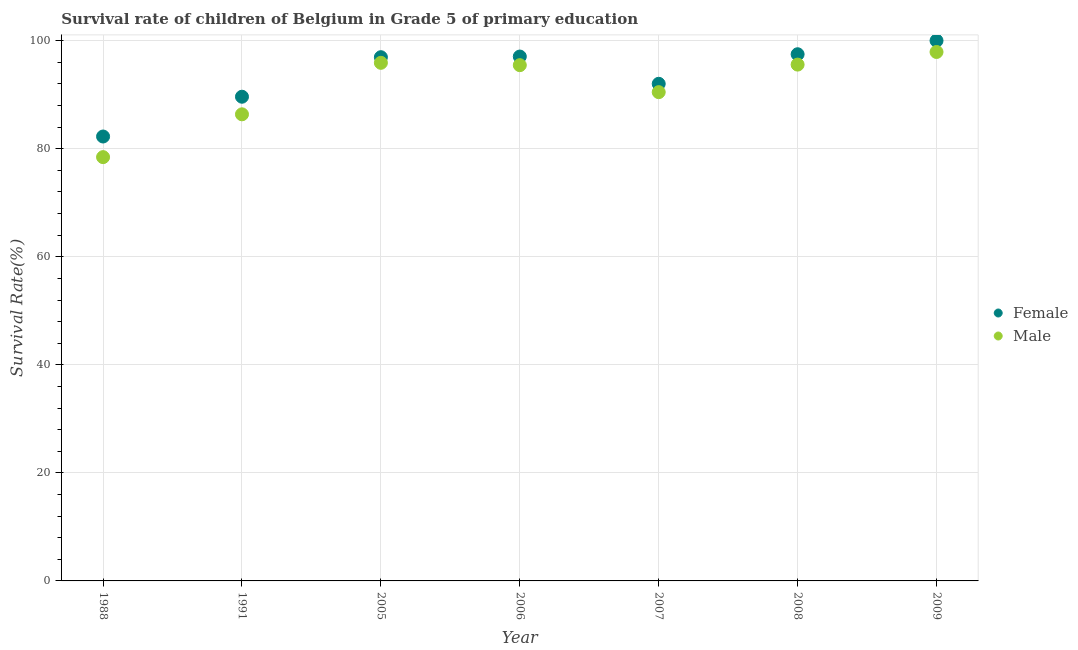Is the number of dotlines equal to the number of legend labels?
Keep it short and to the point. Yes. Across all years, what is the maximum survival rate of male students in primary education?
Offer a very short reply. 97.91. Across all years, what is the minimum survival rate of female students in primary education?
Your response must be concise. 82.26. In which year was the survival rate of male students in primary education minimum?
Offer a very short reply. 1988. What is the total survival rate of female students in primary education in the graph?
Your answer should be very brief. 655.42. What is the difference between the survival rate of female students in primary education in 1991 and that in 2006?
Your answer should be very brief. -7.44. What is the difference between the survival rate of male students in primary education in 2006 and the survival rate of female students in primary education in 1991?
Provide a succinct answer. 5.84. What is the average survival rate of male students in primary education per year?
Provide a succinct answer. 91.45. In the year 2009, what is the difference between the survival rate of female students in primary education and survival rate of male students in primary education?
Your answer should be compact. 2.09. In how many years, is the survival rate of female students in primary education greater than 88 %?
Provide a short and direct response. 6. What is the ratio of the survival rate of female students in primary education in 1991 to that in 2008?
Keep it short and to the point. 0.92. Is the survival rate of male students in primary education in 2006 less than that in 2009?
Provide a succinct answer. Yes. Is the difference between the survival rate of male students in primary education in 1988 and 2008 greater than the difference between the survival rate of female students in primary education in 1988 and 2008?
Keep it short and to the point. No. What is the difference between the highest and the second highest survival rate of male students in primary education?
Offer a very short reply. 2.01. What is the difference between the highest and the lowest survival rate of female students in primary education?
Offer a very short reply. 17.74. Is the sum of the survival rate of male students in primary education in 2006 and 2007 greater than the maximum survival rate of female students in primary education across all years?
Provide a short and direct response. Yes. Does the survival rate of male students in primary education monotonically increase over the years?
Offer a very short reply. No. Is the survival rate of male students in primary education strictly less than the survival rate of female students in primary education over the years?
Ensure brevity in your answer.  Yes. Does the graph contain any zero values?
Provide a short and direct response. No. How many legend labels are there?
Provide a succinct answer. 2. What is the title of the graph?
Your response must be concise. Survival rate of children of Belgium in Grade 5 of primary education. Does "Study and work" appear as one of the legend labels in the graph?
Provide a short and direct response. No. What is the label or title of the Y-axis?
Offer a very short reply. Survival Rate(%). What is the Survival Rate(%) in Female in 1988?
Your response must be concise. 82.26. What is the Survival Rate(%) of Male in 1988?
Your answer should be very brief. 78.45. What is the Survival Rate(%) in Female in 1991?
Make the answer very short. 89.63. What is the Survival Rate(%) in Male in 1991?
Keep it short and to the point. 86.37. What is the Survival Rate(%) of Female in 2005?
Keep it short and to the point. 96.95. What is the Survival Rate(%) in Male in 2005?
Keep it short and to the point. 95.91. What is the Survival Rate(%) in Female in 2006?
Give a very brief answer. 97.07. What is the Survival Rate(%) of Male in 2006?
Offer a terse response. 95.47. What is the Survival Rate(%) of Female in 2007?
Give a very brief answer. 92.02. What is the Survival Rate(%) in Male in 2007?
Give a very brief answer. 90.48. What is the Survival Rate(%) in Female in 2008?
Offer a very short reply. 97.49. What is the Survival Rate(%) in Male in 2008?
Provide a short and direct response. 95.58. What is the Survival Rate(%) in Female in 2009?
Your answer should be compact. 100. What is the Survival Rate(%) in Male in 2009?
Provide a short and direct response. 97.91. Across all years, what is the maximum Survival Rate(%) of Male?
Provide a succinct answer. 97.91. Across all years, what is the minimum Survival Rate(%) in Female?
Keep it short and to the point. 82.26. Across all years, what is the minimum Survival Rate(%) of Male?
Your answer should be compact. 78.45. What is the total Survival Rate(%) of Female in the graph?
Your answer should be very brief. 655.42. What is the total Survival Rate(%) of Male in the graph?
Your response must be concise. 640.16. What is the difference between the Survival Rate(%) of Female in 1988 and that in 1991?
Your answer should be compact. -7.36. What is the difference between the Survival Rate(%) of Male in 1988 and that in 1991?
Your answer should be compact. -7.93. What is the difference between the Survival Rate(%) in Female in 1988 and that in 2005?
Give a very brief answer. -14.68. What is the difference between the Survival Rate(%) of Male in 1988 and that in 2005?
Offer a very short reply. -17.46. What is the difference between the Survival Rate(%) in Female in 1988 and that in 2006?
Your answer should be very brief. -14.8. What is the difference between the Survival Rate(%) of Male in 1988 and that in 2006?
Provide a short and direct response. -17.02. What is the difference between the Survival Rate(%) of Female in 1988 and that in 2007?
Ensure brevity in your answer.  -9.76. What is the difference between the Survival Rate(%) in Male in 1988 and that in 2007?
Offer a terse response. -12.03. What is the difference between the Survival Rate(%) in Female in 1988 and that in 2008?
Your response must be concise. -15.23. What is the difference between the Survival Rate(%) in Male in 1988 and that in 2008?
Your response must be concise. -17.13. What is the difference between the Survival Rate(%) of Female in 1988 and that in 2009?
Your answer should be compact. -17.74. What is the difference between the Survival Rate(%) of Male in 1988 and that in 2009?
Keep it short and to the point. -19.47. What is the difference between the Survival Rate(%) in Female in 1991 and that in 2005?
Provide a short and direct response. -7.32. What is the difference between the Survival Rate(%) in Male in 1991 and that in 2005?
Ensure brevity in your answer.  -9.53. What is the difference between the Survival Rate(%) of Female in 1991 and that in 2006?
Your answer should be compact. -7.44. What is the difference between the Survival Rate(%) of Male in 1991 and that in 2006?
Your answer should be very brief. -9.1. What is the difference between the Survival Rate(%) of Female in 1991 and that in 2007?
Make the answer very short. -2.39. What is the difference between the Survival Rate(%) in Male in 1991 and that in 2007?
Your answer should be compact. -4.1. What is the difference between the Survival Rate(%) of Female in 1991 and that in 2008?
Make the answer very short. -7.86. What is the difference between the Survival Rate(%) of Male in 1991 and that in 2008?
Make the answer very short. -9.2. What is the difference between the Survival Rate(%) in Female in 1991 and that in 2009?
Offer a terse response. -10.37. What is the difference between the Survival Rate(%) of Male in 1991 and that in 2009?
Make the answer very short. -11.54. What is the difference between the Survival Rate(%) of Female in 2005 and that in 2006?
Offer a very short reply. -0.12. What is the difference between the Survival Rate(%) of Male in 2005 and that in 2006?
Keep it short and to the point. 0.43. What is the difference between the Survival Rate(%) of Female in 2005 and that in 2007?
Give a very brief answer. 4.92. What is the difference between the Survival Rate(%) in Male in 2005 and that in 2007?
Offer a terse response. 5.43. What is the difference between the Survival Rate(%) in Female in 2005 and that in 2008?
Provide a succinct answer. -0.55. What is the difference between the Survival Rate(%) of Male in 2005 and that in 2008?
Give a very brief answer. 0.33. What is the difference between the Survival Rate(%) of Female in 2005 and that in 2009?
Provide a short and direct response. -3.05. What is the difference between the Survival Rate(%) of Male in 2005 and that in 2009?
Make the answer very short. -2.01. What is the difference between the Survival Rate(%) of Female in 2006 and that in 2007?
Your answer should be very brief. 5.05. What is the difference between the Survival Rate(%) in Male in 2006 and that in 2007?
Your response must be concise. 5. What is the difference between the Survival Rate(%) of Female in 2006 and that in 2008?
Offer a terse response. -0.42. What is the difference between the Survival Rate(%) of Male in 2006 and that in 2008?
Provide a succinct answer. -0.1. What is the difference between the Survival Rate(%) in Female in 2006 and that in 2009?
Your answer should be very brief. -2.93. What is the difference between the Survival Rate(%) in Male in 2006 and that in 2009?
Your response must be concise. -2.44. What is the difference between the Survival Rate(%) of Female in 2007 and that in 2008?
Your answer should be very brief. -5.47. What is the difference between the Survival Rate(%) of Male in 2007 and that in 2008?
Your answer should be very brief. -5.1. What is the difference between the Survival Rate(%) of Female in 2007 and that in 2009?
Offer a very short reply. -7.98. What is the difference between the Survival Rate(%) in Male in 2007 and that in 2009?
Your response must be concise. -7.44. What is the difference between the Survival Rate(%) in Female in 2008 and that in 2009?
Provide a short and direct response. -2.51. What is the difference between the Survival Rate(%) in Male in 2008 and that in 2009?
Ensure brevity in your answer.  -2.34. What is the difference between the Survival Rate(%) of Female in 1988 and the Survival Rate(%) of Male in 1991?
Give a very brief answer. -4.11. What is the difference between the Survival Rate(%) of Female in 1988 and the Survival Rate(%) of Male in 2005?
Offer a very short reply. -13.64. What is the difference between the Survival Rate(%) of Female in 1988 and the Survival Rate(%) of Male in 2006?
Make the answer very short. -13.21. What is the difference between the Survival Rate(%) in Female in 1988 and the Survival Rate(%) in Male in 2007?
Provide a short and direct response. -8.21. What is the difference between the Survival Rate(%) in Female in 1988 and the Survival Rate(%) in Male in 2008?
Your answer should be very brief. -13.31. What is the difference between the Survival Rate(%) of Female in 1988 and the Survival Rate(%) of Male in 2009?
Offer a terse response. -15.65. What is the difference between the Survival Rate(%) of Female in 1991 and the Survival Rate(%) of Male in 2005?
Your answer should be compact. -6.28. What is the difference between the Survival Rate(%) in Female in 1991 and the Survival Rate(%) in Male in 2006?
Your answer should be very brief. -5.84. What is the difference between the Survival Rate(%) in Female in 1991 and the Survival Rate(%) in Male in 2007?
Provide a succinct answer. -0.85. What is the difference between the Survival Rate(%) in Female in 1991 and the Survival Rate(%) in Male in 2008?
Provide a short and direct response. -5.95. What is the difference between the Survival Rate(%) of Female in 1991 and the Survival Rate(%) of Male in 2009?
Your answer should be compact. -8.28. What is the difference between the Survival Rate(%) of Female in 2005 and the Survival Rate(%) of Male in 2006?
Keep it short and to the point. 1.47. What is the difference between the Survival Rate(%) in Female in 2005 and the Survival Rate(%) in Male in 2007?
Provide a succinct answer. 6.47. What is the difference between the Survival Rate(%) in Female in 2005 and the Survival Rate(%) in Male in 2008?
Offer a very short reply. 1.37. What is the difference between the Survival Rate(%) in Female in 2005 and the Survival Rate(%) in Male in 2009?
Ensure brevity in your answer.  -0.97. What is the difference between the Survival Rate(%) of Female in 2006 and the Survival Rate(%) of Male in 2007?
Make the answer very short. 6.59. What is the difference between the Survival Rate(%) in Female in 2006 and the Survival Rate(%) in Male in 2008?
Keep it short and to the point. 1.49. What is the difference between the Survival Rate(%) in Female in 2006 and the Survival Rate(%) in Male in 2009?
Offer a very short reply. -0.85. What is the difference between the Survival Rate(%) of Female in 2007 and the Survival Rate(%) of Male in 2008?
Ensure brevity in your answer.  -3.55. What is the difference between the Survival Rate(%) of Female in 2007 and the Survival Rate(%) of Male in 2009?
Give a very brief answer. -5.89. What is the difference between the Survival Rate(%) in Female in 2008 and the Survival Rate(%) in Male in 2009?
Provide a short and direct response. -0.42. What is the average Survival Rate(%) of Female per year?
Provide a succinct answer. 93.63. What is the average Survival Rate(%) of Male per year?
Your answer should be very brief. 91.45. In the year 1988, what is the difference between the Survival Rate(%) in Female and Survival Rate(%) in Male?
Provide a succinct answer. 3.82. In the year 1991, what is the difference between the Survival Rate(%) in Female and Survival Rate(%) in Male?
Your answer should be very brief. 3.26. In the year 2005, what is the difference between the Survival Rate(%) of Female and Survival Rate(%) of Male?
Give a very brief answer. 1.04. In the year 2006, what is the difference between the Survival Rate(%) in Female and Survival Rate(%) in Male?
Your answer should be very brief. 1.6. In the year 2007, what is the difference between the Survival Rate(%) of Female and Survival Rate(%) of Male?
Offer a terse response. 1.55. In the year 2008, what is the difference between the Survival Rate(%) in Female and Survival Rate(%) in Male?
Your answer should be compact. 1.92. In the year 2009, what is the difference between the Survival Rate(%) in Female and Survival Rate(%) in Male?
Provide a succinct answer. 2.09. What is the ratio of the Survival Rate(%) in Female in 1988 to that in 1991?
Provide a short and direct response. 0.92. What is the ratio of the Survival Rate(%) of Male in 1988 to that in 1991?
Your answer should be very brief. 0.91. What is the ratio of the Survival Rate(%) of Female in 1988 to that in 2005?
Give a very brief answer. 0.85. What is the ratio of the Survival Rate(%) of Male in 1988 to that in 2005?
Offer a terse response. 0.82. What is the ratio of the Survival Rate(%) in Female in 1988 to that in 2006?
Give a very brief answer. 0.85. What is the ratio of the Survival Rate(%) of Male in 1988 to that in 2006?
Offer a very short reply. 0.82. What is the ratio of the Survival Rate(%) of Female in 1988 to that in 2007?
Your response must be concise. 0.89. What is the ratio of the Survival Rate(%) of Male in 1988 to that in 2007?
Offer a very short reply. 0.87. What is the ratio of the Survival Rate(%) of Female in 1988 to that in 2008?
Your answer should be compact. 0.84. What is the ratio of the Survival Rate(%) in Male in 1988 to that in 2008?
Your response must be concise. 0.82. What is the ratio of the Survival Rate(%) of Female in 1988 to that in 2009?
Provide a short and direct response. 0.82. What is the ratio of the Survival Rate(%) of Male in 1988 to that in 2009?
Give a very brief answer. 0.8. What is the ratio of the Survival Rate(%) of Female in 1991 to that in 2005?
Give a very brief answer. 0.92. What is the ratio of the Survival Rate(%) of Male in 1991 to that in 2005?
Give a very brief answer. 0.9. What is the ratio of the Survival Rate(%) in Female in 1991 to that in 2006?
Ensure brevity in your answer.  0.92. What is the ratio of the Survival Rate(%) of Male in 1991 to that in 2006?
Your response must be concise. 0.9. What is the ratio of the Survival Rate(%) in Female in 1991 to that in 2007?
Offer a very short reply. 0.97. What is the ratio of the Survival Rate(%) in Male in 1991 to that in 2007?
Give a very brief answer. 0.95. What is the ratio of the Survival Rate(%) of Female in 1991 to that in 2008?
Offer a very short reply. 0.92. What is the ratio of the Survival Rate(%) of Male in 1991 to that in 2008?
Offer a terse response. 0.9. What is the ratio of the Survival Rate(%) in Female in 1991 to that in 2009?
Keep it short and to the point. 0.9. What is the ratio of the Survival Rate(%) of Male in 1991 to that in 2009?
Give a very brief answer. 0.88. What is the ratio of the Survival Rate(%) of Female in 2005 to that in 2006?
Your answer should be very brief. 1. What is the ratio of the Survival Rate(%) in Female in 2005 to that in 2007?
Your answer should be compact. 1.05. What is the ratio of the Survival Rate(%) of Male in 2005 to that in 2007?
Ensure brevity in your answer.  1.06. What is the ratio of the Survival Rate(%) of Female in 2005 to that in 2008?
Your answer should be compact. 0.99. What is the ratio of the Survival Rate(%) in Male in 2005 to that in 2008?
Provide a short and direct response. 1. What is the ratio of the Survival Rate(%) of Female in 2005 to that in 2009?
Your answer should be very brief. 0.97. What is the ratio of the Survival Rate(%) of Male in 2005 to that in 2009?
Provide a succinct answer. 0.98. What is the ratio of the Survival Rate(%) in Female in 2006 to that in 2007?
Provide a short and direct response. 1.05. What is the ratio of the Survival Rate(%) of Male in 2006 to that in 2007?
Your response must be concise. 1.06. What is the ratio of the Survival Rate(%) of Male in 2006 to that in 2008?
Your answer should be compact. 1. What is the ratio of the Survival Rate(%) in Female in 2006 to that in 2009?
Provide a short and direct response. 0.97. What is the ratio of the Survival Rate(%) in Male in 2006 to that in 2009?
Offer a very short reply. 0.98. What is the ratio of the Survival Rate(%) in Female in 2007 to that in 2008?
Provide a succinct answer. 0.94. What is the ratio of the Survival Rate(%) of Male in 2007 to that in 2008?
Your answer should be very brief. 0.95. What is the ratio of the Survival Rate(%) of Female in 2007 to that in 2009?
Provide a succinct answer. 0.92. What is the ratio of the Survival Rate(%) in Male in 2007 to that in 2009?
Provide a succinct answer. 0.92. What is the ratio of the Survival Rate(%) in Female in 2008 to that in 2009?
Provide a short and direct response. 0.97. What is the ratio of the Survival Rate(%) in Male in 2008 to that in 2009?
Provide a short and direct response. 0.98. What is the difference between the highest and the second highest Survival Rate(%) of Female?
Ensure brevity in your answer.  2.51. What is the difference between the highest and the second highest Survival Rate(%) in Male?
Provide a short and direct response. 2.01. What is the difference between the highest and the lowest Survival Rate(%) in Female?
Ensure brevity in your answer.  17.74. What is the difference between the highest and the lowest Survival Rate(%) in Male?
Your answer should be very brief. 19.47. 